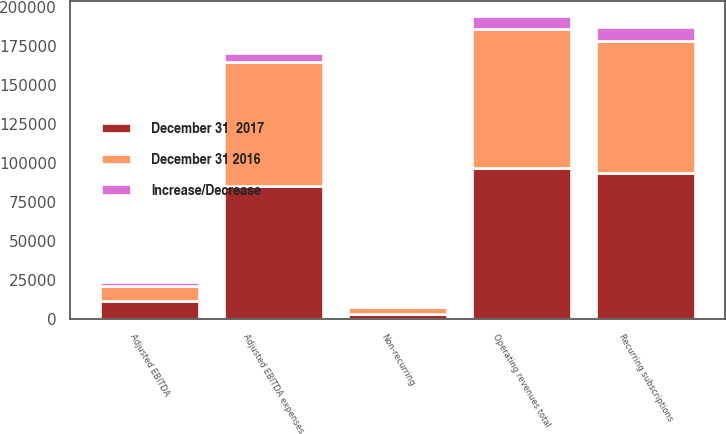<chart> <loc_0><loc_0><loc_500><loc_500><stacked_bar_chart><ecel><fcel>Recurring subscriptions<fcel>Non-recurring<fcel>Operating revenues total<fcel>Adjusted EBITDA expenses<fcel>Adjusted EBITDA<nl><fcel>December 31  2017<fcel>93481<fcel>3463<fcel>96944<fcel>85052<fcel>11892<nl><fcel>December 31 2016<fcel>84457<fcel>4308<fcel>88765<fcel>79293<fcel>9472<nl><fcel>Increase/Decrease<fcel>9024<fcel>845<fcel>8179<fcel>5759<fcel>2420<nl></chart> 